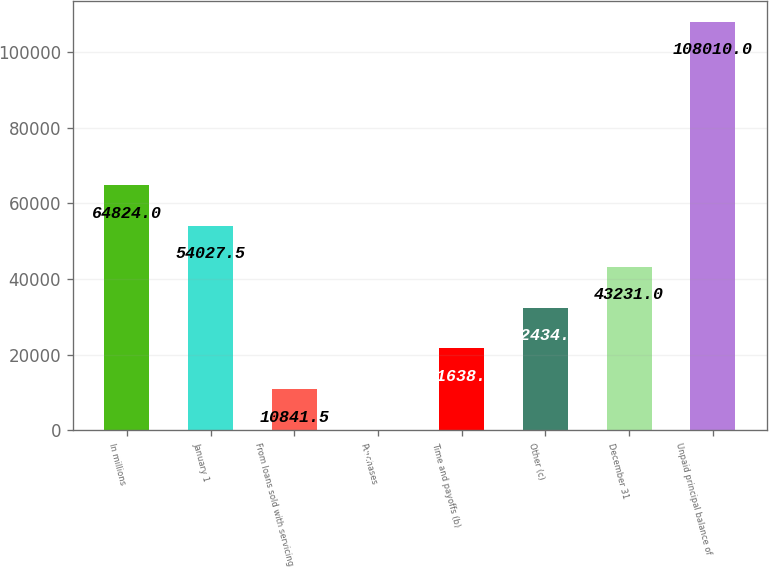Convert chart to OTSL. <chart><loc_0><loc_0><loc_500><loc_500><bar_chart><fcel>In millions<fcel>January 1<fcel>From loans sold with servicing<fcel>Purchases<fcel>Time and payoffs (b)<fcel>Other (c)<fcel>December 31<fcel>Unpaid principal balance of<nl><fcel>64824<fcel>54027.5<fcel>10841.5<fcel>45<fcel>21638<fcel>32434.5<fcel>43231<fcel>108010<nl></chart> 